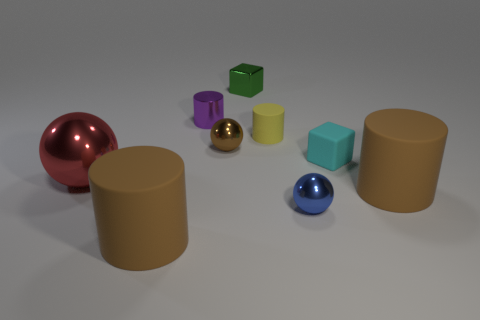Can you describe the colors and textures of the objects in the image? Certainly! In the image, there are objects with a variety of colors and textures. Starting from the left, there is a glossy red sphere, a semi-glossy purple cylinder, a small glossy gold sphere, and a matte green cube. To the right, we see a semi-glossy yellow cylinder, a matte light blue cube, and a matte brown cylinder. The textures range from glossy and shiny to matte and less reflective. 